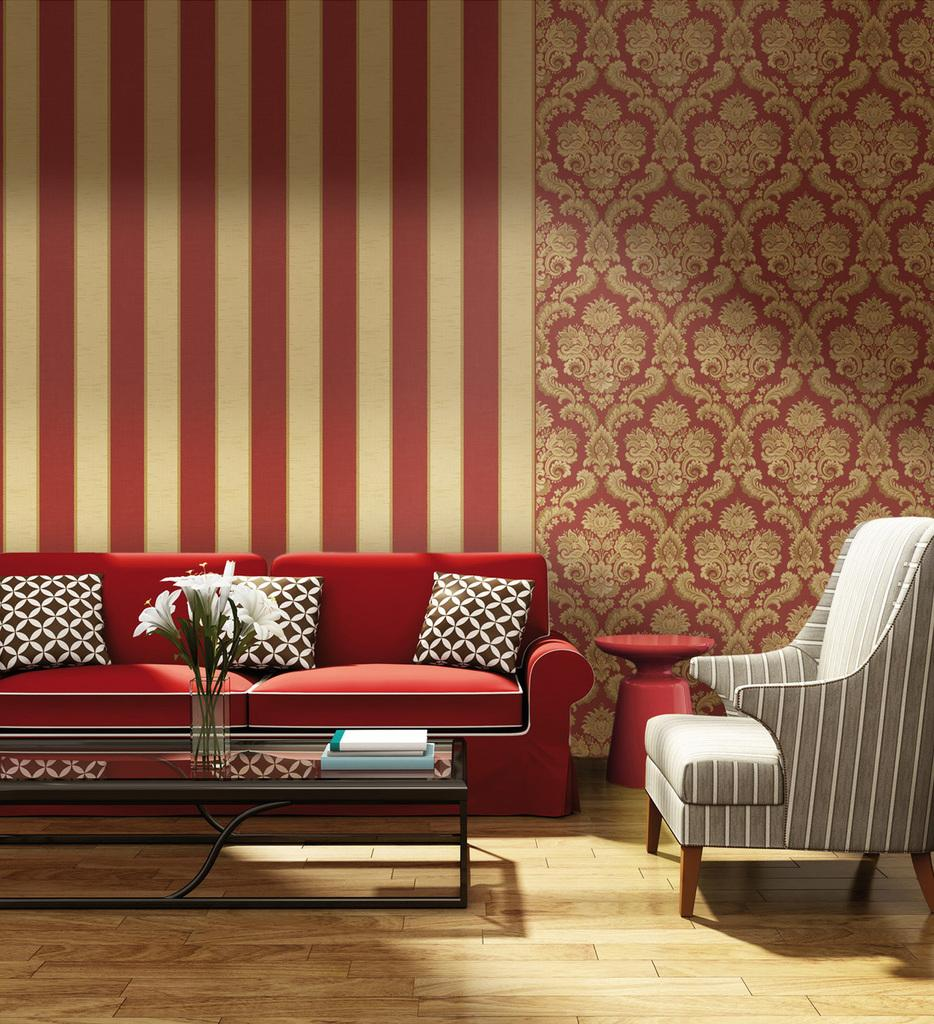What color is the sofa that is the main subject of the image? There is a red sofa in the image. Are there any decorative items on the red sofa? Yes, there are three pillows on the red sofa. What is located beside the red sofa? There is another sofa beside the red sofa. What piece of furniture is in front of the red sofa? There is a table in front of the red sofa. What color is the background wall in the image? The background wall is red in color. What type of skin condition can be seen on the red sofa in the image? There is no skin condition present on the red sofa in the image; it is a piece of furniture. How much dust is visible on the table in the image? The image does not provide information about the presence or amount of dust on the table. 